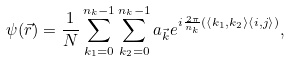<formula> <loc_0><loc_0><loc_500><loc_500>\psi ( \vec { r } ) = \frac { 1 } { N } \sum _ { k _ { 1 } = 0 } ^ { n _ { k } - 1 } \sum _ { k _ { 2 } = 0 } ^ { n _ { k } - 1 } a _ { \vec { k } } e ^ { i \frac { 2 \pi } { n _ { k } } ( { \langle } k _ { 1 } , k _ { 2 } { \rangle } { \langle } i , j { \rangle } ) } ,</formula> 